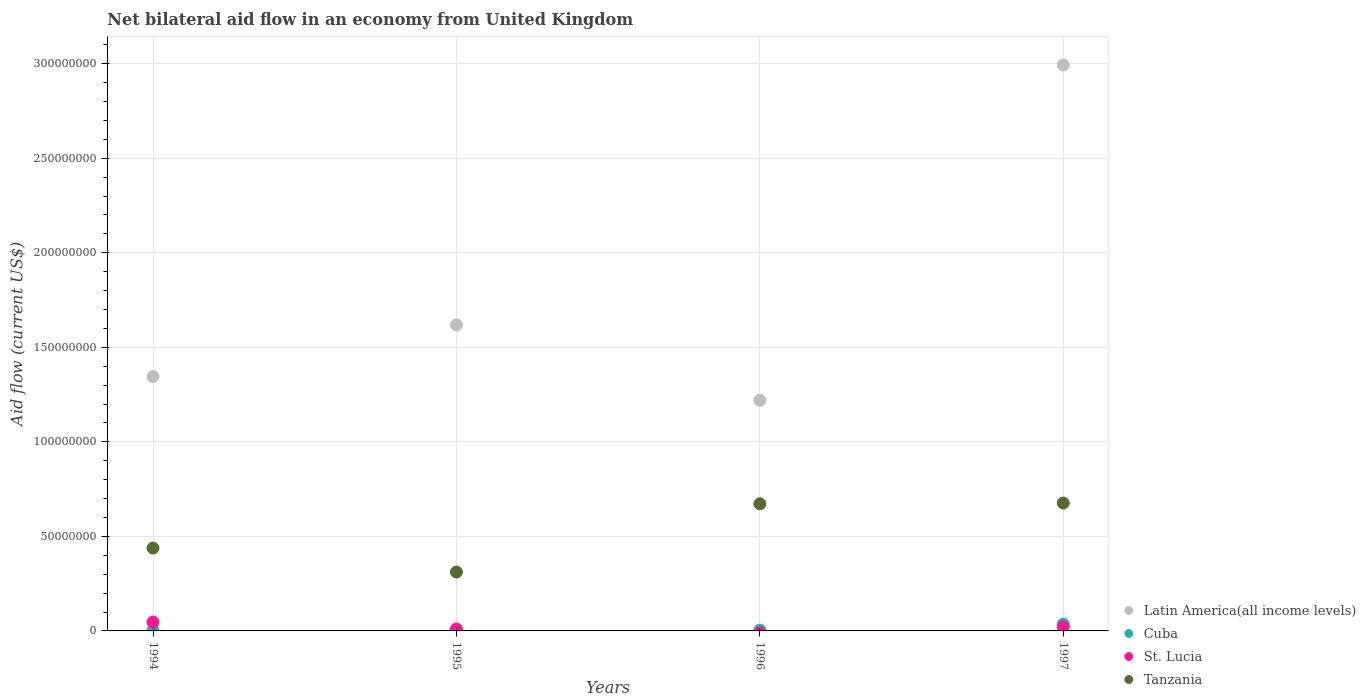How many different coloured dotlines are there?
Keep it short and to the point. 4. What is the net bilateral aid flow in Tanzania in 1994?
Provide a short and direct response. 4.38e+07. Across all years, what is the maximum net bilateral aid flow in St. Lucia?
Provide a succinct answer. 4.70e+06. Across all years, what is the minimum net bilateral aid flow in Latin America(all income levels)?
Offer a terse response. 1.22e+08. What is the total net bilateral aid flow in Cuba in the graph?
Your response must be concise. 4.34e+06. What is the difference between the net bilateral aid flow in St. Lucia in 1997 and the net bilateral aid flow in Latin America(all income levels) in 1995?
Give a very brief answer. -1.60e+08. What is the average net bilateral aid flow in St. Lucia per year?
Provide a succinct answer. 1.98e+06. In the year 1996, what is the difference between the net bilateral aid flow in Latin America(all income levels) and net bilateral aid flow in Tanzania?
Keep it short and to the point. 5.47e+07. In how many years, is the net bilateral aid flow in Tanzania greater than 200000000 US$?
Provide a short and direct response. 0. What is the ratio of the net bilateral aid flow in St. Lucia in 1994 to that in 1995?
Give a very brief answer. 4.61. What is the difference between the highest and the second highest net bilateral aid flow in Cuba?
Provide a succinct answer. 3.17e+06. What is the difference between the highest and the lowest net bilateral aid flow in St. Lucia?
Offer a terse response. 4.70e+06. In how many years, is the net bilateral aid flow in Cuba greater than the average net bilateral aid flow in Cuba taken over all years?
Offer a terse response. 1. Is it the case that in every year, the sum of the net bilateral aid flow in Tanzania and net bilateral aid flow in Cuba  is greater than the net bilateral aid flow in St. Lucia?
Your answer should be very brief. Yes. Does the net bilateral aid flow in Tanzania monotonically increase over the years?
Ensure brevity in your answer.  No. Is the net bilateral aid flow in Cuba strictly less than the net bilateral aid flow in St. Lucia over the years?
Your answer should be very brief. No. How many dotlines are there?
Offer a very short reply. 4. How many years are there in the graph?
Your answer should be compact. 4. What is the difference between two consecutive major ticks on the Y-axis?
Make the answer very short. 5.00e+07. Are the values on the major ticks of Y-axis written in scientific E-notation?
Your answer should be compact. No. Does the graph contain any zero values?
Your response must be concise. Yes. How many legend labels are there?
Your response must be concise. 4. What is the title of the graph?
Ensure brevity in your answer.  Net bilateral aid flow in an economy from United Kingdom. Does "Guam" appear as one of the legend labels in the graph?
Offer a terse response. No. What is the label or title of the X-axis?
Offer a very short reply. Years. What is the Aid flow (current US$) in Latin America(all income levels) in 1994?
Offer a very short reply. 1.35e+08. What is the Aid flow (current US$) in St. Lucia in 1994?
Provide a short and direct response. 4.70e+06. What is the Aid flow (current US$) of Tanzania in 1994?
Keep it short and to the point. 4.38e+07. What is the Aid flow (current US$) in Latin America(all income levels) in 1995?
Your answer should be compact. 1.62e+08. What is the Aid flow (current US$) of Cuba in 1995?
Give a very brief answer. 8.00e+04. What is the Aid flow (current US$) of St. Lucia in 1995?
Your answer should be very brief. 1.02e+06. What is the Aid flow (current US$) of Tanzania in 1995?
Give a very brief answer. 3.12e+07. What is the Aid flow (current US$) in Latin America(all income levels) in 1996?
Provide a succinct answer. 1.22e+08. What is the Aid flow (current US$) in Cuba in 1996?
Offer a terse response. 4.10e+05. What is the Aid flow (current US$) of Tanzania in 1996?
Provide a short and direct response. 6.72e+07. What is the Aid flow (current US$) of Latin America(all income levels) in 1997?
Make the answer very short. 2.99e+08. What is the Aid flow (current US$) of Cuba in 1997?
Provide a succinct answer. 3.58e+06. What is the Aid flow (current US$) of St. Lucia in 1997?
Ensure brevity in your answer.  2.22e+06. What is the Aid flow (current US$) in Tanzania in 1997?
Give a very brief answer. 6.76e+07. Across all years, what is the maximum Aid flow (current US$) of Latin America(all income levels)?
Ensure brevity in your answer.  2.99e+08. Across all years, what is the maximum Aid flow (current US$) of Cuba?
Make the answer very short. 3.58e+06. Across all years, what is the maximum Aid flow (current US$) of St. Lucia?
Give a very brief answer. 4.70e+06. Across all years, what is the maximum Aid flow (current US$) in Tanzania?
Provide a short and direct response. 6.76e+07. Across all years, what is the minimum Aid flow (current US$) of Latin America(all income levels)?
Provide a short and direct response. 1.22e+08. Across all years, what is the minimum Aid flow (current US$) in Cuba?
Provide a succinct answer. 8.00e+04. Across all years, what is the minimum Aid flow (current US$) in St. Lucia?
Your answer should be very brief. 0. Across all years, what is the minimum Aid flow (current US$) of Tanzania?
Give a very brief answer. 3.12e+07. What is the total Aid flow (current US$) in Latin America(all income levels) in the graph?
Keep it short and to the point. 7.18e+08. What is the total Aid flow (current US$) of Cuba in the graph?
Provide a succinct answer. 4.34e+06. What is the total Aid flow (current US$) of St. Lucia in the graph?
Your answer should be very brief. 7.94e+06. What is the total Aid flow (current US$) in Tanzania in the graph?
Offer a terse response. 2.10e+08. What is the difference between the Aid flow (current US$) of Latin America(all income levels) in 1994 and that in 1995?
Your answer should be compact. -2.74e+07. What is the difference between the Aid flow (current US$) in Cuba in 1994 and that in 1995?
Give a very brief answer. 1.90e+05. What is the difference between the Aid flow (current US$) in St. Lucia in 1994 and that in 1995?
Ensure brevity in your answer.  3.68e+06. What is the difference between the Aid flow (current US$) of Tanzania in 1994 and that in 1995?
Provide a short and direct response. 1.27e+07. What is the difference between the Aid flow (current US$) in Latin America(all income levels) in 1994 and that in 1996?
Your answer should be very brief. 1.26e+07. What is the difference between the Aid flow (current US$) of Tanzania in 1994 and that in 1996?
Keep it short and to the point. -2.34e+07. What is the difference between the Aid flow (current US$) in Latin America(all income levels) in 1994 and that in 1997?
Give a very brief answer. -1.65e+08. What is the difference between the Aid flow (current US$) of Cuba in 1994 and that in 1997?
Give a very brief answer. -3.31e+06. What is the difference between the Aid flow (current US$) of St. Lucia in 1994 and that in 1997?
Your answer should be compact. 2.48e+06. What is the difference between the Aid flow (current US$) of Tanzania in 1994 and that in 1997?
Provide a short and direct response. -2.38e+07. What is the difference between the Aid flow (current US$) of Latin America(all income levels) in 1995 and that in 1996?
Ensure brevity in your answer.  4.00e+07. What is the difference between the Aid flow (current US$) of Cuba in 1995 and that in 1996?
Your answer should be compact. -3.30e+05. What is the difference between the Aid flow (current US$) in Tanzania in 1995 and that in 1996?
Provide a succinct answer. -3.61e+07. What is the difference between the Aid flow (current US$) in Latin America(all income levels) in 1995 and that in 1997?
Your response must be concise. -1.37e+08. What is the difference between the Aid flow (current US$) of Cuba in 1995 and that in 1997?
Provide a short and direct response. -3.50e+06. What is the difference between the Aid flow (current US$) of St. Lucia in 1995 and that in 1997?
Your response must be concise. -1.20e+06. What is the difference between the Aid flow (current US$) in Tanzania in 1995 and that in 1997?
Offer a very short reply. -3.65e+07. What is the difference between the Aid flow (current US$) in Latin America(all income levels) in 1996 and that in 1997?
Your answer should be compact. -1.77e+08. What is the difference between the Aid flow (current US$) of Cuba in 1996 and that in 1997?
Make the answer very short. -3.17e+06. What is the difference between the Aid flow (current US$) of Tanzania in 1996 and that in 1997?
Make the answer very short. -3.80e+05. What is the difference between the Aid flow (current US$) of Latin America(all income levels) in 1994 and the Aid flow (current US$) of Cuba in 1995?
Ensure brevity in your answer.  1.34e+08. What is the difference between the Aid flow (current US$) in Latin America(all income levels) in 1994 and the Aid flow (current US$) in St. Lucia in 1995?
Keep it short and to the point. 1.34e+08. What is the difference between the Aid flow (current US$) in Latin America(all income levels) in 1994 and the Aid flow (current US$) in Tanzania in 1995?
Give a very brief answer. 1.03e+08. What is the difference between the Aid flow (current US$) of Cuba in 1994 and the Aid flow (current US$) of St. Lucia in 1995?
Provide a short and direct response. -7.50e+05. What is the difference between the Aid flow (current US$) of Cuba in 1994 and the Aid flow (current US$) of Tanzania in 1995?
Your answer should be compact. -3.09e+07. What is the difference between the Aid flow (current US$) of St. Lucia in 1994 and the Aid flow (current US$) of Tanzania in 1995?
Your answer should be very brief. -2.64e+07. What is the difference between the Aid flow (current US$) in Latin America(all income levels) in 1994 and the Aid flow (current US$) in Cuba in 1996?
Make the answer very short. 1.34e+08. What is the difference between the Aid flow (current US$) in Latin America(all income levels) in 1994 and the Aid flow (current US$) in Tanzania in 1996?
Your response must be concise. 6.73e+07. What is the difference between the Aid flow (current US$) in Cuba in 1994 and the Aid flow (current US$) in Tanzania in 1996?
Offer a very short reply. -6.70e+07. What is the difference between the Aid flow (current US$) in St. Lucia in 1994 and the Aid flow (current US$) in Tanzania in 1996?
Provide a succinct answer. -6.26e+07. What is the difference between the Aid flow (current US$) of Latin America(all income levels) in 1994 and the Aid flow (current US$) of Cuba in 1997?
Your response must be concise. 1.31e+08. What is the difference between the Aid flow (current US$) of Latin America(all income levels) in 1994 and the Aid flow (current US$) of St. Lucia in 1997?
Keep it short and to the point. 1.32e+08. What is the difference between the Aid flow (current US$) of Latin America(all income levels) in 1994 and the Aid flow (current US$) of Tanzania in 1997?
Keep it short and to the point. 6.69e+07. What is the difference between the Aid flow (current US$) in Cuba in 1994 and the Aid flow (current US$) in St. Lucia in 1997?
Your answer should be compact. -1.95e+06. What is the difference between the Aid flow (current US$) of Cuba in 1994 and the Aid flow (current US$) of Tanzania in 1997?
Provide a succinct answer. -6.74e+07. What is the difference between the Aid flow (current US$) in St. Lucia in 1994 and the Aid flow (current US$) in Tanzania in 1997?
Ensure brevity in your answer.  -6.29e+07. What is the difference between the Aid flow (current US$) of Latin America(all income levels) in 1995 and the Aid flow (current US$) of Cuba in 1996?
Offer a terse response. 1.62e+08. What is the difference between the Aid flow (current US$) of Latin America(all income levels) in 1995 and the Aid flow (current US$) of Tanzania in 1996?
Your answer should be compact. 9.47e+07. What is the difference between the Aid flow (current US$) of Cuba in 1995 and the Aid flow (current US$) of Tanzania in 1996?
Your answer should be compact. -6.72e+07. What is the difference between the Aid flow (current US$) in St. Lucia in 1995 and the Aid flow (current US$) in Tanzania in 1996?
Offer a terse response. -6.62e+07. What is the difference between the Aid flow (current US$) in Latin America(all income levels) in 1995 and the Aid flow (current US$) in Cuba in 1997?
Provide a succinct answer. 1.58e+08. What is the difference between the Aid flow (current US$) in Latin America(all income levels) in 1995 and the Aid flow (current US$) in St. Lucia in 1997?
Make the answer very short. 1.60e+08. What is the difference between the Aid flow (current US$) in Latin America(all income levels) in 1995 and the Aid flow (current US$) in Tanzania in 1997?
Your response must be concise. 9.43e+07. What is the difference between the Aid flow (current US$) in Cuba in 1995 and the Aid flow (current US$) in St. Lucia in 1997?
Provide a short and direct response. -2.14e+06. What is the difference between the Aid flow (current US$) of Cuba in 1995 and the Aid flow (current US$) of Tanzania in 1997?
Your answer should be very brief. -6.76e+07. What is the difference between the Aid flow (current US$) in St. Lucia in 1995 and the Aid flow (current US$) in Tanzania in 1997?
Make the answer very short. -6.66e+07. What is the difference between the Aid flow (current US$) in Latin America(all income levels) in 1996 and the Aid flow (current US$) in Cuba in 1997?
Provide a short and direct response. 1.18e+08. What is the difference between the Aid flow (current US$) in Latin America(all income levels) in 1996 and the Aid flow (current US$) in St. Lucia in 1997?
Offer a very short reply. 1.20e+08. What is the difference between the Aid flow (current US$) of Latin America(all income levels) in 1996 and the Aid flow (current US$) of Tanzania in 1997?
Give a very brief answer. 5.43e+07. What is the difference between the Aid flow (current US$) of Cuba in 1996 and the Aid flow (current US$) of St. Lucia in 1997?
Offer a terse response. -1.81e+06. What is the difference between the Aid flow (current US$) in Cuba in 1996 and the Aid flow (current US$) in Tanzania in 1997?
Your response must be concise. -6.72e+07. What is the average Aid flow (current US$) in Latin America(all income levels) per year?
Ensure brevity in your answer.  1.79e+08. What is the average Aid flow (current US$) in Cuba per year?
Give a very brief answer. 1.08e+06. What is the average Aid flow (current US$) in St. Lucia per year?
Offer a terse response. 1.98e+06. What is the average Aid flow (current US$) of Tanzania per year?
Offer a very short reply. 5.25e+07. In the year 1994, what is the difference between the Aid flow (current US$) in Latin America(all income levels) and Aid flow (current US$) in Cuba?
Make the answer very short. 1.34e+08. In the year 1994, what is the difference between the Aid flow (current US$) in Latin America(all income levels) and Aid flow (current US$) in St. Lucia?
Ensure brevity in your answer.  1.30e+08. In the year 1994, what is the difference between the Aid flow (current US$) of Latin America(all income levels) and Aid flow (current US$) of Tanzania?
Offer a terse response. 9.07e+07. In the year 1994, what is the difference between the Aid flow (current US$) of Cuba and Aid flow (current US$) of St. Lucia?
Your response must be concise. -4.43e+06. In the year 1994, what is the difference between the Aid flow (current US$) of Cuba and Aid flow (current US$) of Tanzania?
Ensure brevity in your answer.  -4.36e+07. In the year 1994, what is the difference between the Aid flow (current US$) of St. Lucia and Aid flow (current US$) of Tanzania?
Offer a terse response. -3.91e+07. In the year 1995, what is the difference between the Aid flow (current US$) of Latin America(all income levels) and Aid flow (current US$) of Cuba?
Provide a succinct answer. 1.62e+08. In the year 1995, what is the difference between the Aid flow (current US$) in Latin America(all income levels) and Aid flow (current US$) in St. Lucia?
Give a very brief answer. 1.61e+08. In the year 1995, what is the difference between the Aid flow (current US$) in Latin America(all income levels) and Aid flow (current US$) in Tanzania?
Provide a short and direct response. 1.31e+08. In the year 1995, what is the difference between the Aid flow (current US$) of Cuba and Aid flow (current US$) of St. Lucia?
Ensure brevity in your answer.  -9.40e+05. In the year 1995, what is the difference between the Aid flow (current US$) in Cuba and Aid flow (current US$) in Tanzania?
Make the answer very short. -3.11e+07. In the year 1995, what is the difference between the Aid flow (current US$) in St. Lucia and Aid flow (current US$) in Tanzania?
Ensure brevity in your answer.  -3.01e+07. In the year 1996, what is the difference between the Aid flow (current US$) of Latin America(all income levels) and Aid flow (current US$) of Cuba?
Give a very brief answer. 1.22e+08. In the year 1996, what is the difference between the Aid flow (current US$) of Latin America(all income levels) and Aid flow (current US$) of Tanzania?
Make the answer very short. 5.47e+07. In the year 1996, what is the difference between the Aid flow (current US$) of Cuba and Aid flow (current US$) of Tanzania?
Provide a succinct answer. -6.68e+07. In the year 1997, what is the difference between the Aid flow (current US$) of Latin America(all income levels) and Aid flow (current US$) of Cuba?
Give a very brief answer. 2.96e+08. In the year 1997, what is the difference between the Aid flow (current US$) of Latin America(all income levels) and Aid flow (current US$) of St. Lucia?
Provide a succinct answer. 2.97e+08. In the year 1997, what is the difference between the Aid flow (current US$) of Latin America(all income levels) and Aid flow (current US$) of Tanzania?
Provide a short and direct response. 2.32e+08. In the year 1997, what is the difference between the Aid flow (current US$) of Cuba and Aid flow (current US$) of St. Lucia?
Make the answer very short. 1.36e+06. In the year 1997, what is the difference between the Aid flow (current US$) of Cuba and Aid flow (current US$) of Tanzania?
Your answer should be compact. -6.40e+07. In the year 1997, what is the difference between the Aid flow (current US$) in St. Lucia and Aid flow (current US$) in Tanzania?
Ensure brevity in your answer.  -6.54e+07. What is the ratio of the Aid flow (current US$) in Latin America(all income levels) in 1994 to that in 1995?
Offer a very short reply. 0.83. What is the ratio of the Aid flow (current US$) of Cuba in 1994 to that in 1995?
Ensure brevity in your answer.  3.38. What is the ratio of the Aid flow (current US$) in St. Lucia in 1994 to that in 1995?
Ensure brevity in your answer.  4.61. What is the ratio of the Aid flow (current US$) in Tanzania in 1994 to that in 1995?
Ensure brevity in your answer.  1.41. What is the ratio of the Aid flow (current US$) in Latin America(all income levels) in 1994 to that in 1996?
Keep it short and to the point. 1.1. What is the ratio of the Aid flow (current US$) of Cuba in 1994 to that in 1996?
Offer a terse response. 0.66. What is the ratio of the Aid flow (current US$) of Tanzania in 1994 to that in 1996?
Keep it short and to the point. 0.65. What is the ratio of the Aid flow (current US$) in Latin America(all income levels) in 1994 to that in 1997?
Give a very brief answer. 0.45. What is the ratio of the Aid flow (current US$) of Cuba in 1994 to that in 1997?
Provide a short and direct response. 0.08. What is the ratio of the Aid flow (current US$) in St. Lucia in 1994 to that in 1997?
Offer a terse response. 2.12. What is the ratio of the Aid flow (current US$) in Tanzania in 1994 to that in 1997?
Provide a succinct answer. 0.65. What is the ratio of the Aid flow (current US$) of Latin America(all income levels) in 1995 to that in 1996?
Make the answer very short. 1.33. What is the ratio of the Aid flow (current US$) of Cuba in 1995 to that in 1996?
Provide a succinct answer. 0.2. What is the ratio of the Aid flow (current US$) in Tanzania in 1995 to that in 1996?
Your response must be concise. 0.46. What is the ratio of the Aid flow (current US$) of Latin America(all income levels) in 1995 to that in 1997?
Offer a terse response. 0.54. What is the ratio of the Aid flow (current US$) of Cuba in 1995 to that in 1997?
Ensure brevity in your answer.  0.02. What is the ratio of the Aid flow (current US$) in St. Lucia in 1995 to that in 1997?
Keep it short and to the point. 0.46. What is the ratio of the Aid flow (current US$) in Tanzania in 1995 to that in 1997?
Offer a very short reply. 0.46. What is the ratio of the Aid flow (current US$) of Latin America(all income levels) in 1996 to that in 1997?
Offer a terse response. 0.41. What is the ratio of the Aid flow (current US$) in Cuba in 1996 to that in 1997?
Provide a succinct answer. 0.11. What is the ratio of the Aid flow (current US$) in Tanzania in 1996 to that in 1997?
Provide a succinct answer. 0.99. What is the difference between the highest and the second highest Aid flow (current US$) of Latin America(all income levels)?
Keep it short and to the point. 1.37e+08. What is the difference between the highest and the second highest Aid flow (current US$) of Cuba?
Provide a short and direct response. 3.17e+06. What is the difference between the highest and the second highest Aid flow (current US$) of St. Lucia?
Provide a succinct answer. 2.48e+06. What is the difference between the highest and the lowest Aid flow (current US$) of Latin America(all income levels)?
Make the answer very short. 1.77e+08. What is the difference between the highest and the lowest Aid flow (current US$) of Cuba?
Ensure brevity in your answer.  3.50e+06. What is the difference between the highest and the lowest Aid flow (current US$) in St. Lucia?
Give a very brief answer. 4.70e+06. What is the difference between the highest and the lowest Aid flow (current US$) of Tanzania?
Make the answer very short. 3.65e+07. 